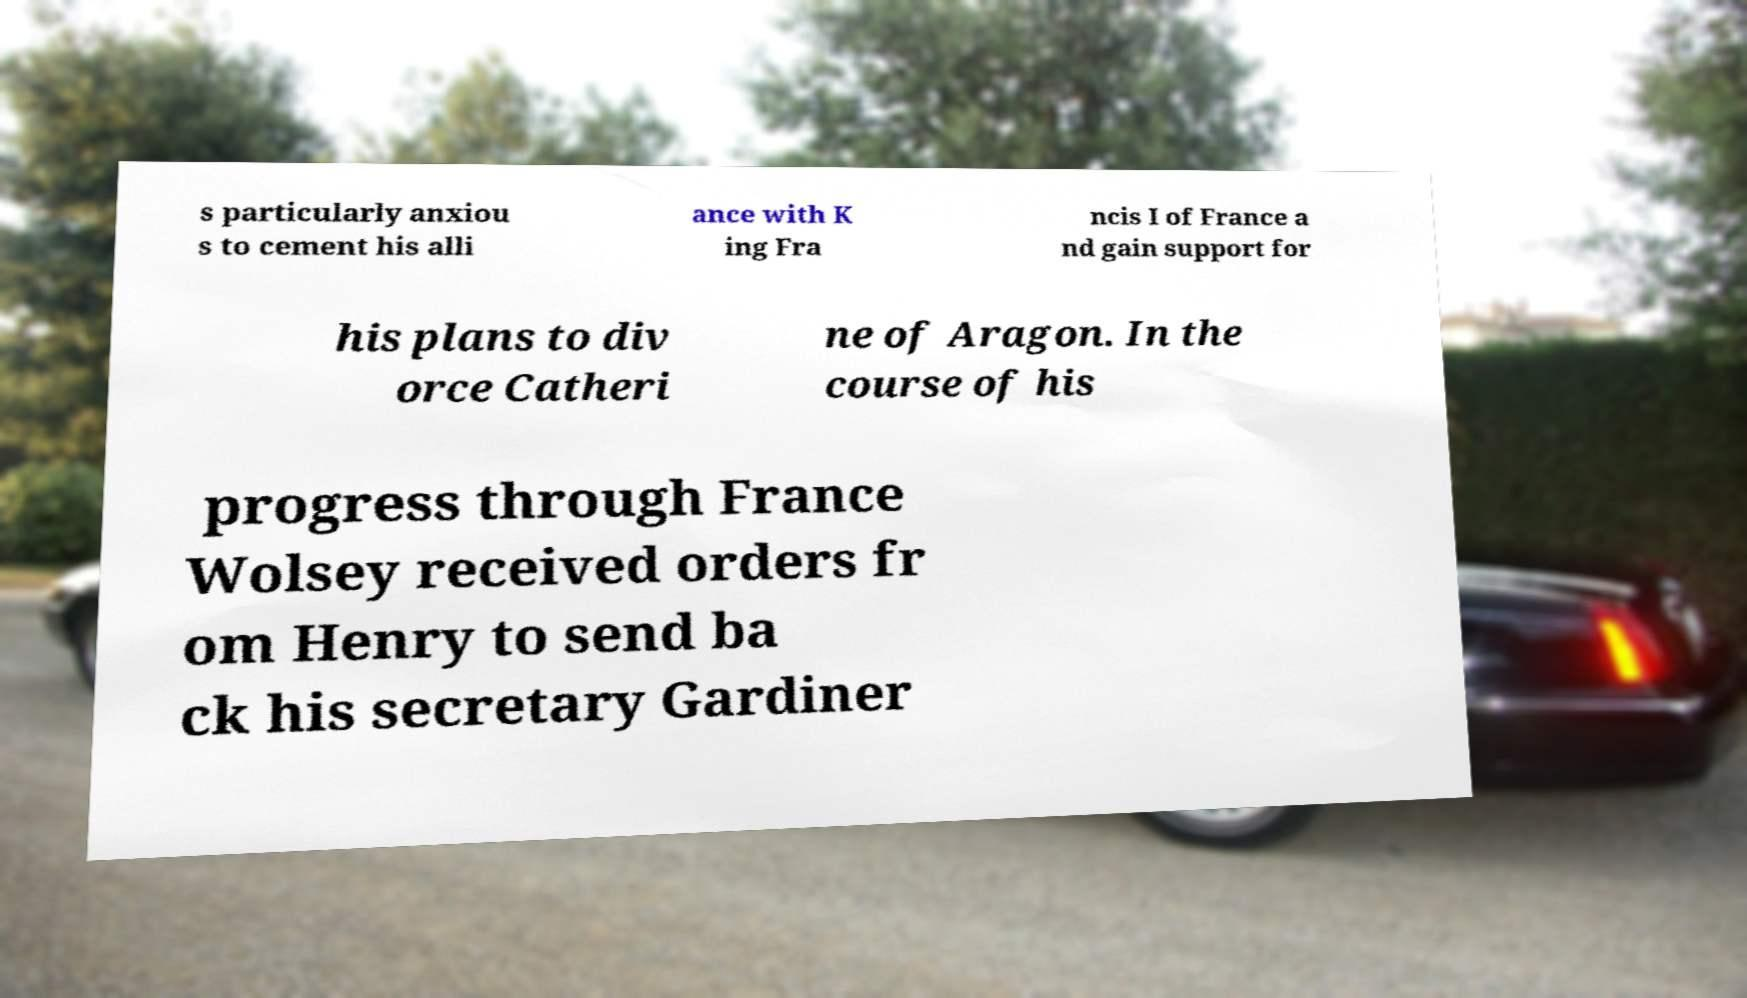Please read and relay the text visible in this image. What does it say? s particularly anxiou s to cement his alli ance with K ing Fra ncis I of France a nd gain support for his plans to div orce Catheri ne of Aragon. In the course of his progress through France Wolsey received orders fr om Henry to send ba ck his secretary Gardiner 